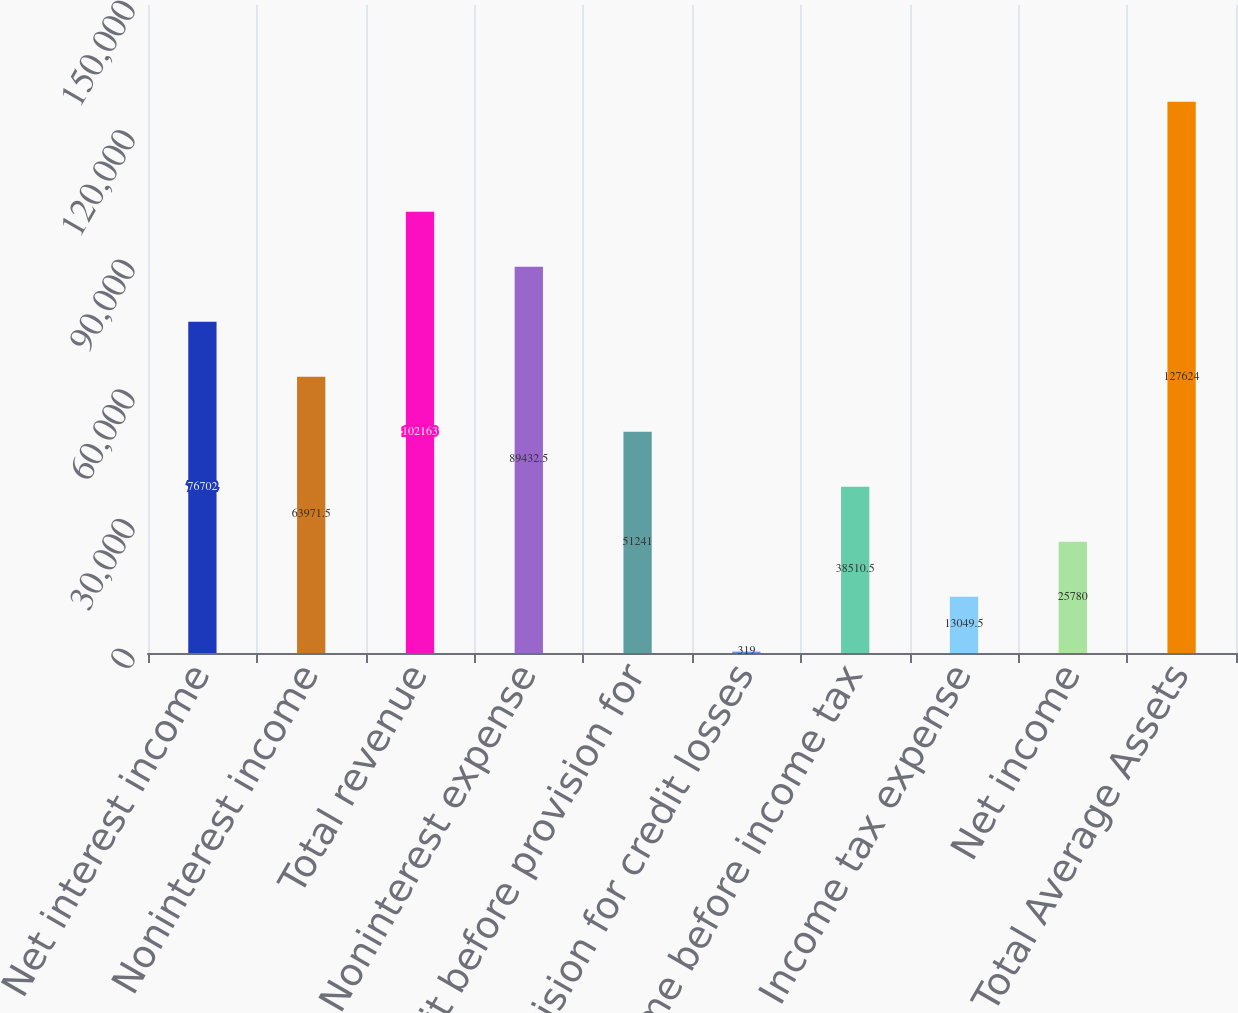<chart> <loc_0><loc_0><loc_500><loc_500><bar_chart><fcel>Net interest income<fcel>Noninterest income<fcel>Total revenue<fcel>Noninterest expense<fcel>Profit before provision for<fcel>Provision for credit losses<fcel>Income before income tax<fcel>Income tax expense<fcel>Net income<fcel>Total Average Assets<nl><fcel>76702<fcel>63971.5<fcel>102163<fcel>89432.5<fcel>51241<fcel>319<fcel>38510.5<fcel>13049.5<fcel>25780<fcel>127624<nl></chart> 